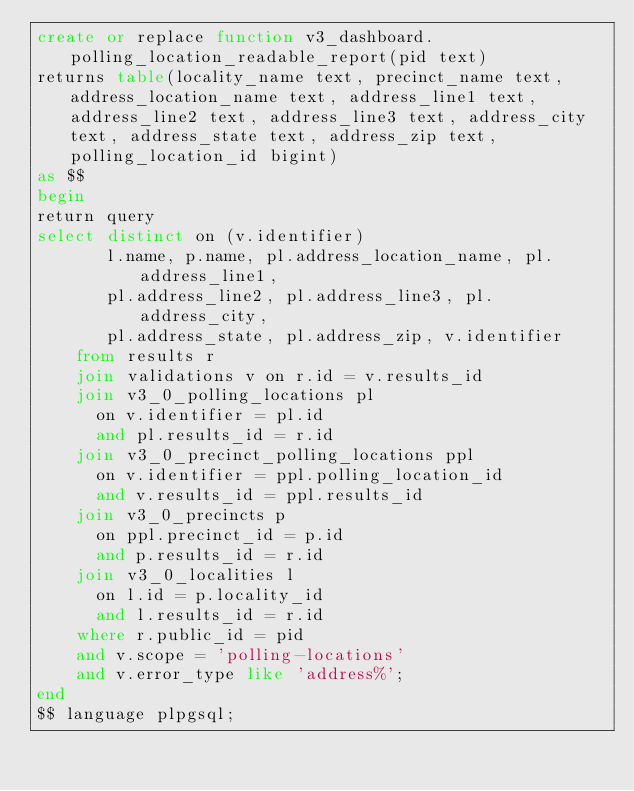Convert code to text. <code><loc_0><loc_0><loc_500><loc_500><_SQL_>create or replace function v3_dashboard.polling_location_readable_report(pid text)
returns table(locality_name text, precinct_name text, address_location_name text, address_line1 text, address_line2 text, address_line3 text, address_city text, address_state text, address_zip text, polling_location_id bigint)
as $$
begin
return query
select distinct on (v.identifier)
       l.name, p.name, pl.address_location_name, pl.address_line1,
       pl.address_line2, pl.address_line3, pl.address_city,
       pl.address_state, pl.address_zip, v.identifier
    from results r
    join validations v on r.id = v.results_id
    join v3_0_polling_locations pl
      on v.identifier = pl.id
      and pl.results_id = r.id
    join v3_0_precinct_polling_locations ppl
      on v.identifier = ppl.polling_location_id
      and v.results_id = ppl.results_id
    join v3_0_precincts p
      on ppl.precinct_id = p.id
      and p.results_id = r.id
    join v3_0_localities l
      on l.id = p.locality_id
      and l.results_id = r.id
    where r.public_id = pid
    and v.scope = 'polling-locations'
    and v.error_type like 'address%';
end
$$ language plpgsql;
</code> 